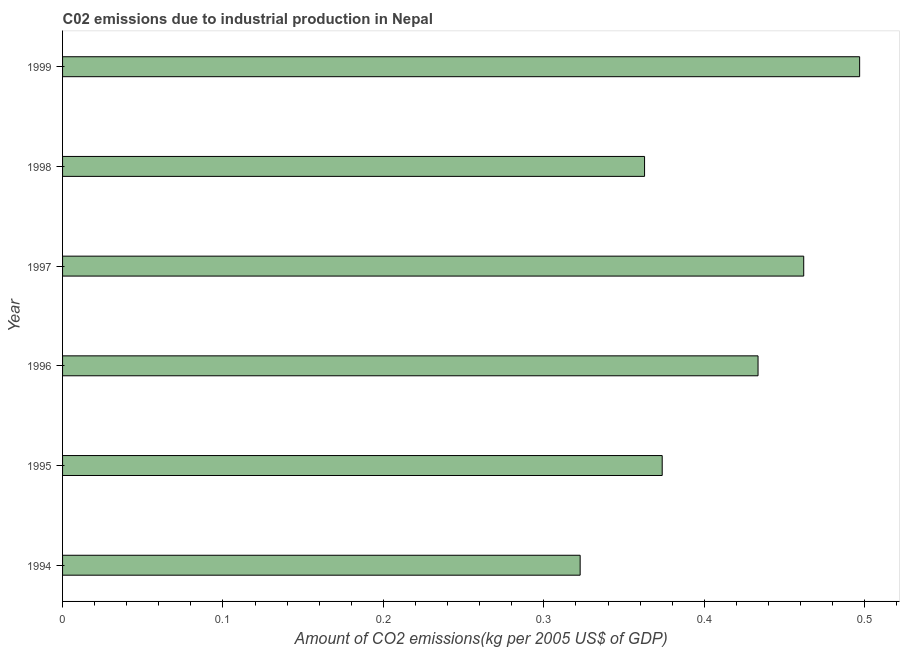Does the graph contain any zero values?
Give a very brief answer. No. Does the graph contain grids?
Your answer should be very brief. No. What is the title of the graph?
Provide a short and direct response. C02 emissions due to industrial production in Nepal. What is the label or title of the X-axis?
Provide a succinct answer. Amount of CO2 emissions(kg per 2005 US$ of GDP). What is the amount of co2 emissions in 1997?
Offer a very short reply. 0.46. Across all years, what is the maximum amount of co2 emissions?
Your response must be concise. 0.5. Across all years, what is the minimum amount of co2 emissions?
Offer a very short reply. 0.32. What is the sum of the amount of co2 emissions?
Keep it short and to the point. 2.45. What is the difference between the amount of co2 emissions in 1997 and 1999?
Offer a very short reply. -0.04. What is the average amount of co2 emissions per year?
Provide a succinct answer. 0.41. What is the median amount of co2 emissions?
Keep it short and to the point. 0.4. What is the ratio of the amount of co2 emissions in 1995 to that in 1998?
Your response must be concise. 1.03. Is the difference between the amount of co2 emissions in 1994 and 1995 greater than the difference between any two years?
Give a very brief answer. No. What is the difference between the highest and the second highest amount of co2 emissions?
Make the answer very short. 0.04. What is the difference between the highest and the lowest amount of co2 emissions?
Offer a very short reply. 0.17. In how many years, is the amount of co2 emissions greater than the average amount of co2 emissions taken over all years?
Offer a terse response. 3. How many bars are there?
Keep it short and to the point. 6. Are all the bars in the graph horizontal?
Offer a terse response. Yes. Are the values on the major ticks of X-axis written in scientific E-notation?
Your answer should be very brief. No. What is the Amount of CO2 emissions(kg per 2005 US$ of GDP) of 1994?
Provide a succinct answer. 0.32. What is the Amount of CO2 emissions(kg per 2005 US$ of GDP) in 1995?
Your answer should be compact. 0.37. What is the Amount of CO2 emissions(kg per 2005 US$ of GDP) of 1996?
Ensure brevity in your answer.  0.43. What is the Amount of CO2 emissions(kg per 2005 US$ of GDP) of 1997?
Give a very brief answer. 0.46. What is the Amount of CO2 emissions(kg per 2005 US$ of GDP) of 1998?
Your answer should be very brief. 0.36. What is the Amount of CO2 emissions(kg per 2005 US$ of GDP) of 1999?
Make the answer very short. 0.5. What is the difference between the Amount of CO2 emissions(kg per 2005 US$ of GDP) in 1994 and 1995?
Your answer should be very brief. -0.05. What is the difference between the Amount of CO2 emissions(kg per 2005 US$ of GDP) in 1994 and 1996?
Ensure brevity in your answer.  -0.11. What is the difference between the Amount of CO2 emissions(kg per 2005 US$ of GDP) in 1994 and 1997?
Offer a very short reply. -0.14. What is the difference between the Amount of CO2 emissions(kg per 2005 US$ of GDP) in 1994 and 1998?
Give a very brief answer. -0.04. What is the difference between the Amount of CO2 emissions(kg per 2005 US$ of GDP) in 1994 and 1999?
Your answer should be very brief. -0.17. What is the difference between the Amount of CO2 emissions(kg per 2005 US$ of GDP) in 1995 and 1996?
Ensure brevity in your answer.  -0.06. What is the difference between the Amount of CO2 emissions(kg per 2005 US$ of GDP) in 1995 and 1997?
Provide a short and direct response. -0.09. What is the difference between the Amount of CO2 emissions(kg per 2005 US$ of GDP) in 1995 and 1998?
Provide a short and direct response. 0.01. What is the difference between the Amount of CO2 emissions(kg per 2005 US$ of GDP) in 1995 and 1999?
Keep it short and to the point. -0.12. What is the difference between the Amount of CO2 emissions(kg per 2005 US$ of GDP) in 1996 and 1997?
Your answer should be compact. -0.03. What is the difference between the Amount of CO2 emissions(kg per 2005 US$ of GDP) in 1996 and 1998?
Your answer should be very brief. 0.07. What is the difference between the Amount of CO2 emissions(kg per 2005 US$ of GDP) in 1996 and 1999?
Give a very brief answer. -0.06. What is the difference between the Amount of CO2 emissions(kg per 2005 US$ of GDP) in 1997 and 1998?
Ensure brevity in your answer.  0.1. What is the difference between the Amount of CO2 emissions(kg per 2005 US$ of GDP) in 1997 and 1999?
Give a very brief answer. -0.03. What is the difference between the Amount of CO2 emissions(kg per 2005 US$ of GDP) in 1998 and 1999?
Give a very brief answer. -0.13. What is the ratio of the Amount of CO2 emissions(kg per 2005 US$ of GDP) in 1994 to that in 1995?
Your answer should be very brief. 0.86. What is the ratio of the Amount of CO2 emissions(kg per 2005 US$ of GDP) in 1994 to that in 1996?
Your answer should be very brief. 0.74. What is the ratio of the Amount of CO2 emissions(kg per 2005 US$ of GDP) in 1994 to that in 1997?
Keep it short and to the point. 0.7. What is the ratio of the Amount of CO2 emissions(kg per 2005 US$ of GDP) in 1994 to that in 1998?
Your answer should be very brief. 0.89. What is the ratio of the Amount of CO2 emissions(kg per 2005 US$ of GDP) in 1994 to that in 1999?
Make the answer very short. 0.65. What is the ratio of the Amount of CO2 emissions(kg per 2005 US$ of GDP) in 1995 to that in 1996?
Your answer should be very brief. 0.86. What is the ratio of the Amount of CO2 emissions(kg per 2005 US$ of GDP) in 1995 to that in 1997?
Give a very brief answer. 0.81. What is the ratio of the Amount of CO2 emissions(kg per 2005 US$ of GDP) in 1995 to that in 1998?
Offer a terse response. 1.03. What is the ratio of the Amount of CO2 emissions(kg per 2005 US$ of GDP) in 1995 to that in 1999?
Your answer should be very brief. 0.75. What is the ratio of the Amount of CO2 emissions(kg per 2005 US$ of GDP) in 1996 to that in 1997?
Ensure brevity in your answer.  0.94. What is the ratio of the Amount of CO2 emissions(kg per 2005 US$ of GDP) in 1996 to that in 1998?
Give a very brief answer. 1.2. What is the ratio of the Amount of CO2 emissions(kg per 2005 US$ of GDP) in 1996 to that in 1999?
Ensure brevity in your answer.  0.87. What is the ratio of the Amount of CO2 emissions(kg per 2005 US$ of GDP) in 1997 to that in 1998?
Offer a terse response. 1.27. What is the ratio of the Amount of CO2 emissions(kg per 2005 US$ of GDP) in 1997 to that in 1999?
Ensure brevity in your answer.  0.93. What is the ratio of the Amount of CO2 emissions(kg per 2005 US$ of GDP) in 1998 to that in 1999?
Offer a terse response. 0.73. 